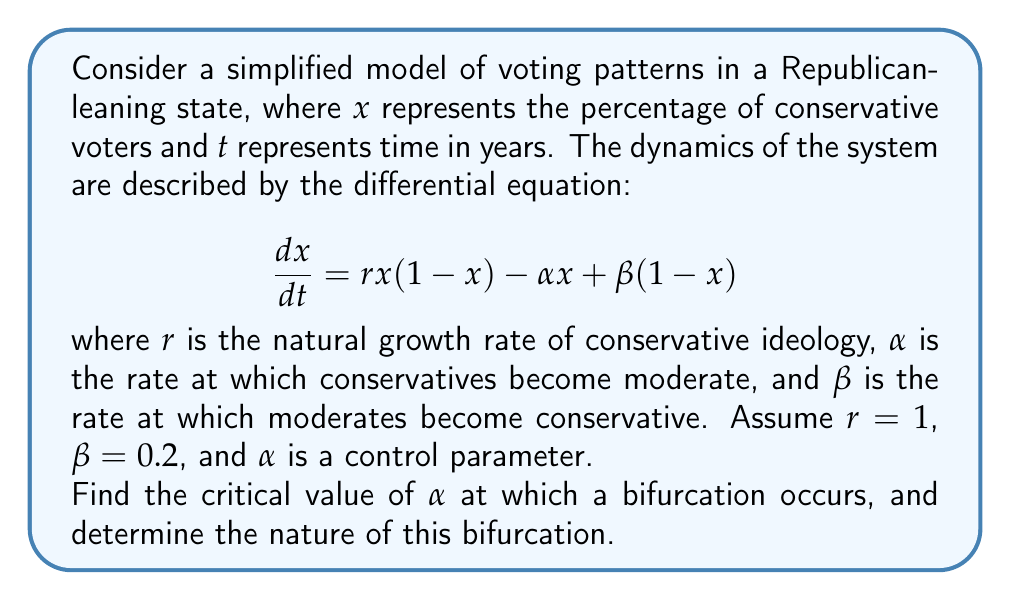Show me your answer to this math problem. To solve this problem, we'll follow these steps:

1) First, we need to find the equilibrium points of the system by setting $\frac{dx}{dt} = 0$:

   $$rx(1-x) - \alpha x + \beta(1-x) = 0$$

2) Substituting the given values and simplifying:

   $$x(1-x) - \alpha x + 0.2(1-x) = 0$$
   $$x - x^2 - \alpha x + 0.2 - 0.2x = 0$$
   $$-x^2 + (0.8-\alpha)x + 0.2 = 0$$

3) This is a quadratic equation in $x$. For a bifurcation to occur, this equation should have a double root, which happens when its discriminant is zero. The discriminant is given by $b^2 - 4ac$ where $a$, $b$, and $c$ are the coefficients of the quadratic equation in standard form $(ax^2 + bx + c)$.

4) In this case:
   $a = -1$
   $b = 0.8-\alpha$
   $c = 0.2$

5) Setting the discriminant to zero:

   $$(0.8-\alpha)^2 - 4(-1)(0.2) = 0$$
   $$(0.8-\alpha)^2 = 0.8$$

6) Solving this equation:

   $$0.8-\alpha = \pm\sqrt{0.8}$$
   $$\alpha = 0.8 \pm \sqrt{0.8}$$

7) Since $\alpha$ represents a rate, it must be positive. Therefore:

   $$\alpha = 0.8 + \sqrt{0.8} \approx 1.6944$$

8) At this critical value of $\alpha$, the system undergoes a saddle-node bifurcation. This type of bifurcation occurs when two equilibrium points (one stable and one unstable) collide and annihilate each other.

9) For $\alpha < 1.6944$, the system has two equilibrium points (one stable and one unstable). For $\alpha > 1.6944$, there are no equilibrium points, indicating a shift towards a more moderate voter base.
Answer: $\alpha_{critical} \approx 1.6944$; Saddle-node bifurcation 